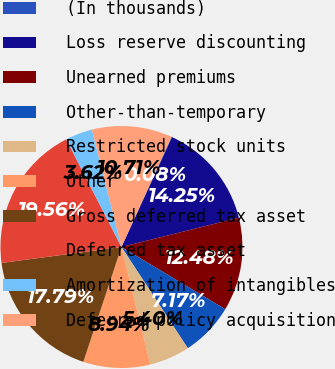Convert chart. <chart><loc_0><loc_0><loc_500><loc_500><pie_chart><fcel>(In thousands)<fcel>Loss reserve discounting<fcel>Unearned premiums<fcel>Other-than-temporary<fcel>Restricted stock units<fcel>Other<fcel>Gross deferred tax asset<fcel>Deferred tax asset<fcel>Amortization of intangibles<fcel>Deferred policy acquisition<nl><fcel>0.08%<fcel>14.25%<fcel>12.48%<fcel>7.17%<fcel>5.4%<fcel>8.94%<fcel>17.79%<fcel>19.56%<fcel>3.62%<fcel>10.71%<nl></chart> 